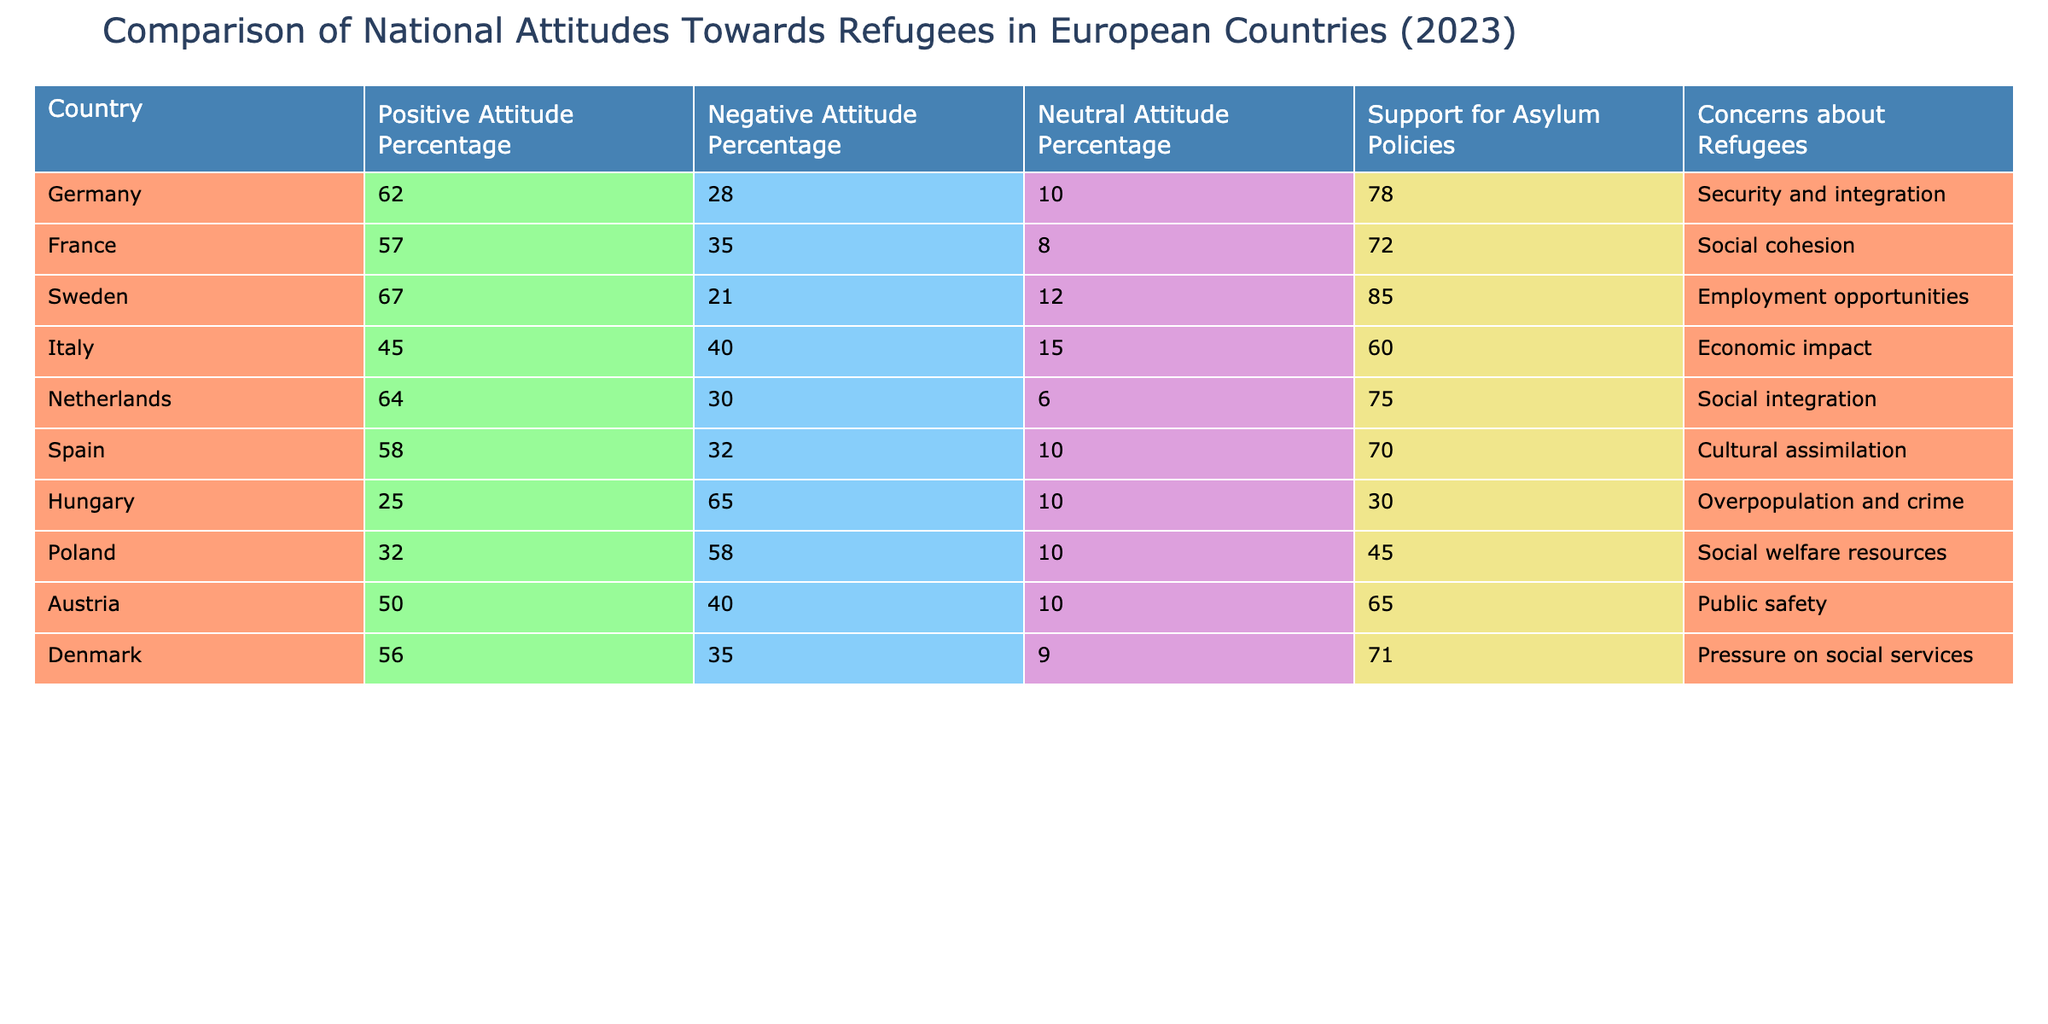What is the percentage of positive attitudes towards refugees in Germany? The table indicates that in Germany, the percentage of positive attitudes is listed directly under the "Positive Attitude Percentage" column, which shows a value of 62.
Answer: 62 Which country has the highest percentage of positive attitudes towards refugees? By comparing the "Positive Attitude Percentage" across all countries in the table, Sweden has the highest percentage at 67.
Answer: Sweden What is the average percentage of negative attitudes towards refugees across the listed countries? To find the average, we add up the negative attitude percentages: 28 + 35 + 21 + 40 + 30 + 32 + 65 + 58 + 40 + 35 =  424. Dividing by the total number of countries (10), we get an average of 42.4.
Answer: 42.4 Is it true that Hungary has a higher negative attitude percentage than Italy? In the table, Hungary's negative attitude percentage is 65, whereas Italy's is 40. Since 65 is greater than 40, the statement is true.
Answer: Yes What concerns do the Netherlands and France share regarding refugees? Looking at the "Concerns about Refugees" column for both countries, the Netherlands lists "Social integration," while France lists "Social cohesion." Both concerns relate to social issues, indicating a similar focus on societal aspects.
Answer: No Which country has the lowest support for asylum policies among the listed countries? By examining the "Support for Asylum Policies" column, Hungary has the lowest value at 30, making it the country with the least support for these policies.
Answer: Hungary What is the difference in support for asylum policies between Sweden and Italy? The support for asylum policies in Sweden is 85 and in Italy it is 60. The difference is calculated by subtracting the two values: 85 - 60 = 25.
Answer: 25 Which country has a neutral attitude percentage of 10%? The table shows that both Hungary and Poland have a neutral attitude percentage of 10%. Therefore, both countries fit the criteria.
Answer: Hungary, Poland 